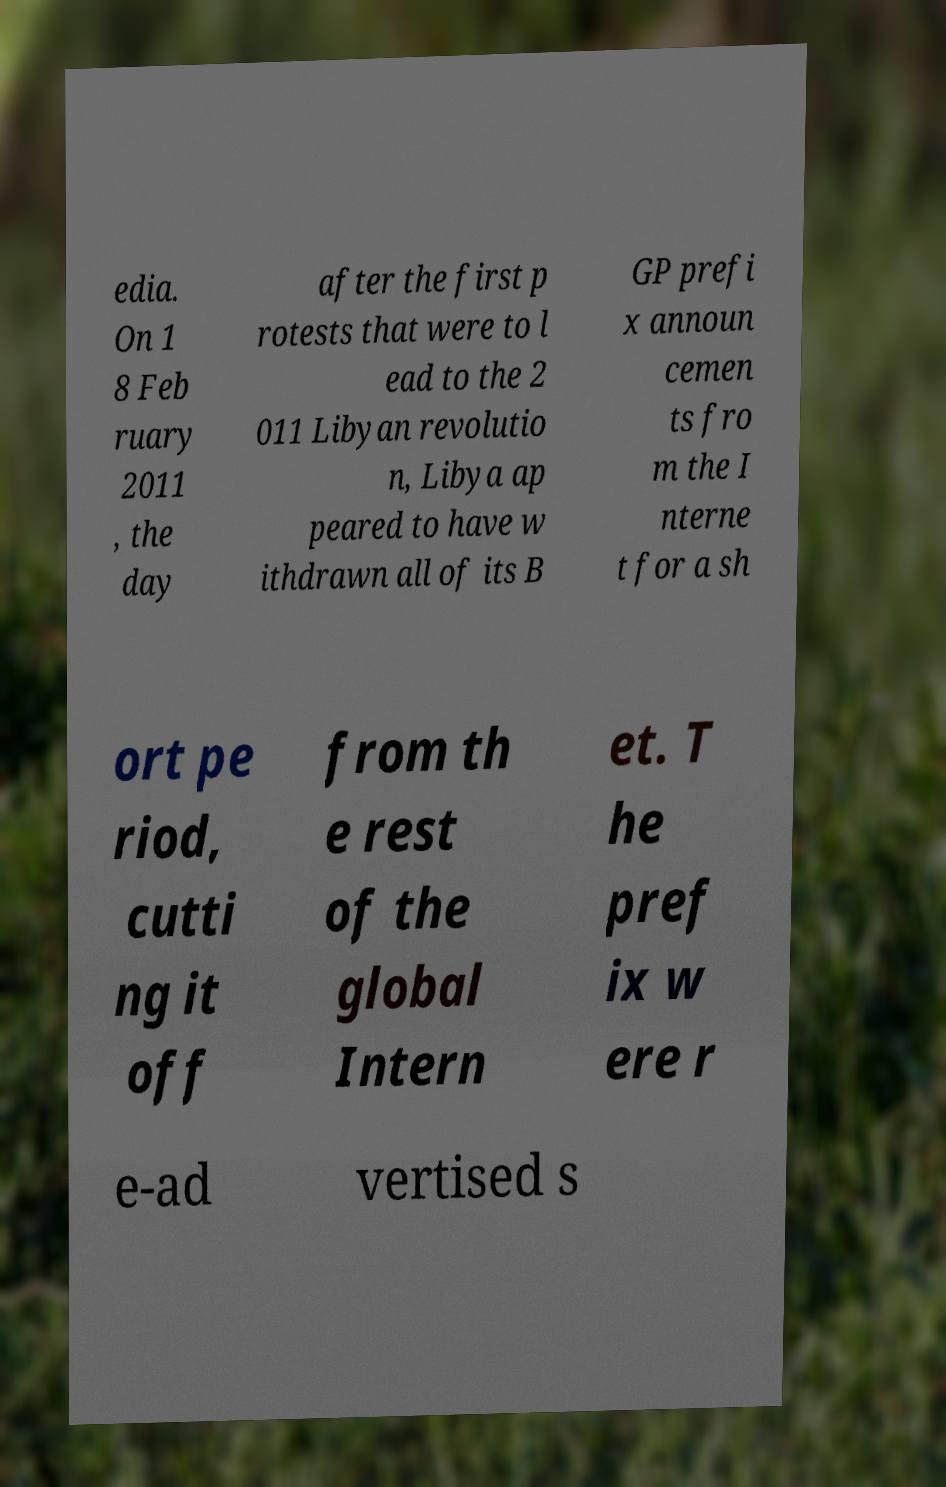For documentation purposes, I need the text within this image transcribed. Could you provide that? edia. On 1 8 Feb ruary 2011 , the day after the first p rotests that were to l ead to the 2 011 Libyan revolutio n, Libya ap peared to have w ithdrawn all of its B GP prefi x announ cemen ts fro m the I nterne t for a sh ort pe riod, cutti ng it off from th e rest of the global Intern et. T he pref ix w ere r e-ad vertised s 